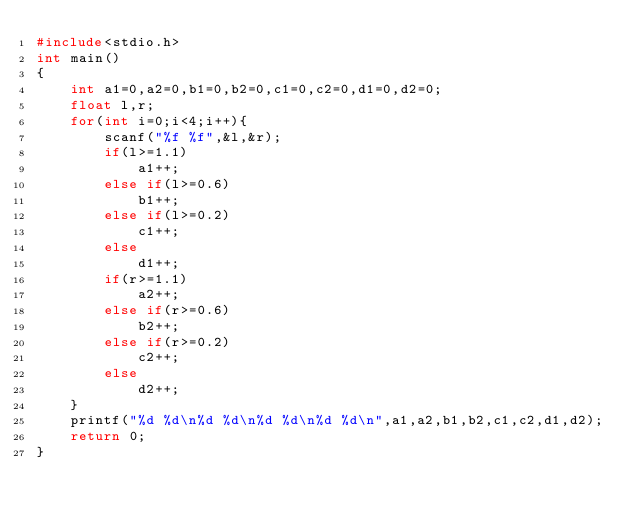<code> <loc_0><loc_0><loc_500><loc_500><_C++_>#include<stdio.h>
int main()
{
	int a1=0,a2=0,b1=0,b2=0,c1=0,c2=0,d1=0,d2=0;
	float l,r;
	for(int i=0;i<4;i++){
		scanf("%f %f",&l,&r);
		if(l>=1.1)
			a1++;
		else if(l>=0.6)
			b1++;
		else if(l>=0.2)
			c1++;
		else
			d1++;
		if(r>=1.1)
			a2++;
		else if(r>=0.6)
			b2++;
		else if(r>=0.2)
			c2++;
		else
			d2++;
	}
	printf("%d %d\n%d %d\n%d %d\n%d %d\n",a1,a2,b1,b2,c1,c2,d1,d2);
	return 0;
}</code> 